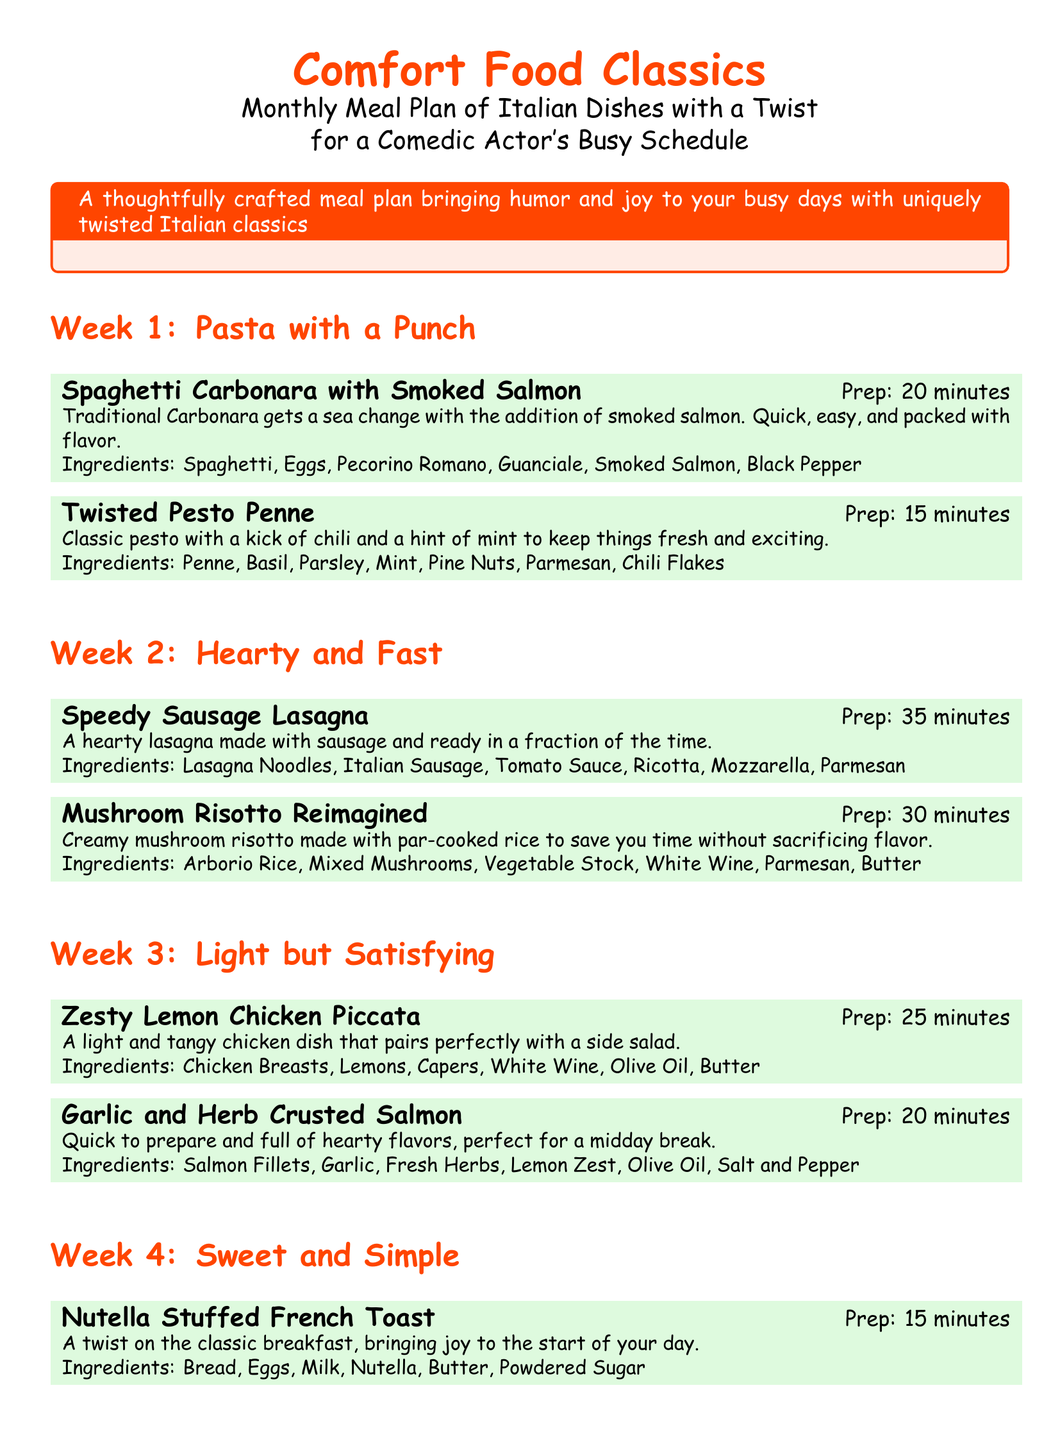What is the title of the meal plan? The title appears prominently at the top of the document, highlighting its focus on comfort food.
Answer: Comfort Food Classics How many meals are in Week 1? Each week features two meals, and Week 1 is no exception.
Answer: 2 What is the prep time for Nutella Stuffed French Toast? The preparation time for this dish is explicitly stated next to the meal title.
Answer: 15 minutes Which ingredient is used in both Spaghetti Carbonara with Smoked Salmon and Espresso Tiramisu? The document lists ingredients under each meal, allowing for easy comparison.
Answer: Eggs What is a key twist in Twisted Pesto Penne? The description highlights a unique ingredient that sets this meal apart from traditional pesto.
Answer: Chili What does the meal plan help a comedic actor manage? The document outlines that this meal plan is catered to a specific profession's needs and schedules.
Answer: Busy schedule Which meal takes the longest to prepare in Week 2? The meal preparation times are provided, allowing for a straightforward comparison of durations.
Answer: Speedy Sausage Lasagna How is Mushroom Risotto described in terms of cooking time? The description includes a specific adjustment that makes this dish quicker to prepare, relating it to overall cooking strategy.
Answer: Par-cooked rice What type of cuisine does this meal plan focus on? The document is themed around a specific culinary tradition, as evidenced by its title and meal selections.
Answer: Italian 